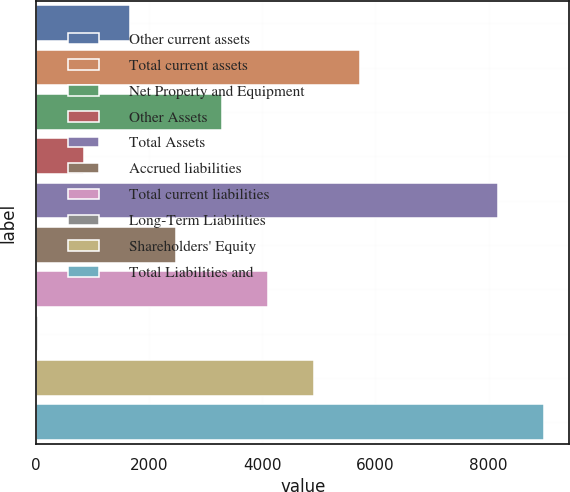Convert chart to OTSL. <chart><loc_0><loc_0><loc_500><loc_500><bar_chart><fcel>Other current assets<fcel>Total current assets<fcel>Net Property and Equipment<fcel>Other Assets<fcel>Total Assets<fcel>Accrued liabilities<fcel>Total current liabilities<fcel>Long-Term Liabilities<fcel>Shareholders' Equity<fcel>Total Liabilities and<nl><fcel>1657.6<fcel>5724.1<fcel>3284.2<fcel>844.3<fcel>8164<fcel>2470.9<fcel>4097.5<fcel>31<fcel>4910.8<fcel>8977.3<nl></chart> 